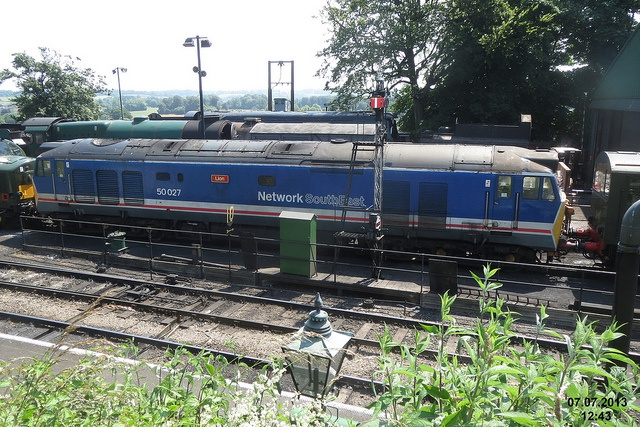Describe the objects in this image and their specific colors. I can see train in white, black, navy, gray, and darkgray tones, train in white, black, blue, gray, and lightgray tones, and train in white, black, gray, and darkgray tones in this image. 